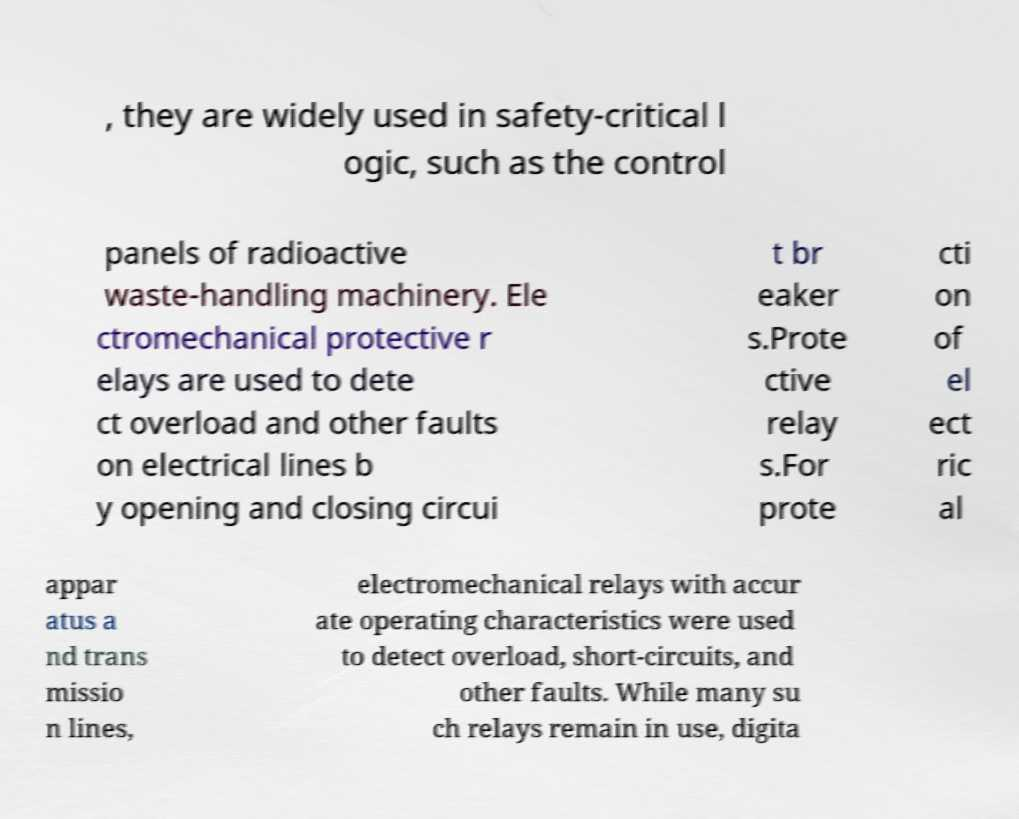Please read and relay the text visible in this image. What does it say? , they are widely used in safety-critical l ogic, such as the control panels of radioactive waste-handling machinery. Ele ctromechanical protective r elays are used to dete ct overload and other faults on electrical lines b y opening and closing circui t br eaker s.Prote ctive relay s.For prote cti on of el ect ric al appar atus a nd trans missio n lines, electromechanical relays with accur ate operating characteristics were used to detect overload, short-circuits, and other faults. While many su ch relays remain in use, digita 